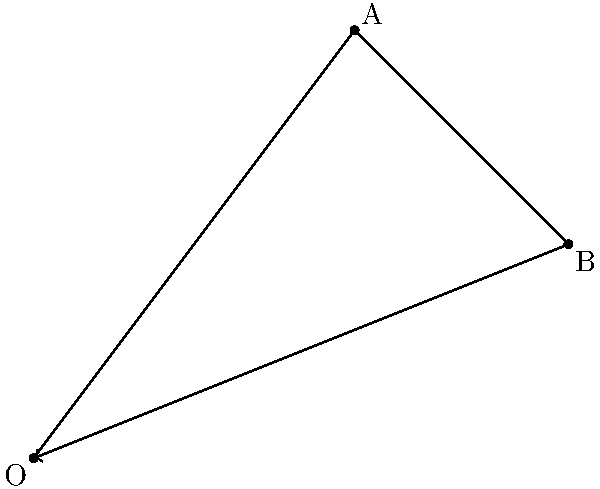As an entrepreneur launching a new product, you map its market position using 2D vectors. The initial launch vector is $\vec{OA} = \langle 3, 4 \rangle$, representing market share and customer satisfaction. Due to a competitor's action, there's a market shift represented by vector $\vec{AB} = \langle 2, -2 \rangle$. What is the magnitude of the resultant vector $\vec{OB}$, representing the final market position? Let's approach this step-by-step:

1) We need to find vector $\vec{OB}$. We can do this by adding vectors $\vec{OA}$ and $\vec{AB}$:

   $\vec{OB} = \vec{OA} + \vec{AB}$

2) We're given:
   $\vec{OA} = \langle 3, 4 \rangle$
   $\vec{AB} = \langle 2, -2 \rangle$

3) Adding these vectors:
   $\vec{OB} = \langle 3, 4 \rangle + \langle 2, -2 \rangle = \langle 5, 2 \rangle$

4) To find the magnitude of $\vec{OB}$, we use the Pythagorean theorem:

   $|\vec{OB}| = \sqrt{x^2 + y^2}$

   Where $x$ and $y$ are the components of $\vec{OB}$.

5) Substituting the values:

   $|\vec{OB}| = \sqrt{5^2 + 2^2} = \sqrt{25 + 4} = \sqrt{29}$

Therefore, the magnitude of the resultant vector $\vec{OB}$ is $\sqrt{29}$.
Answer: $\sqrt{29}$ 